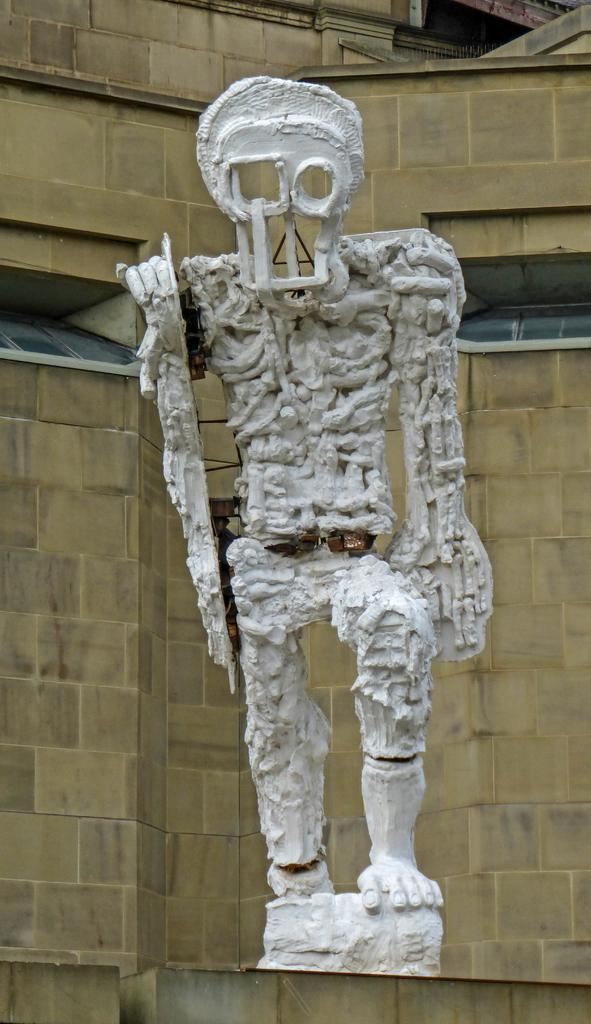What is the main subject of the image? There is a white color sculpture in the image. What can be seen in the background of the image? There is a yellow color wall in the background of the image. How does the sculpture waste resources in the image? The sculpture does not waste resources in the image; it is a static object. Is there any indication of an attack happening in the image? There is no indication of an attack happening in the image; it features a sculpture and a yellow wall. 